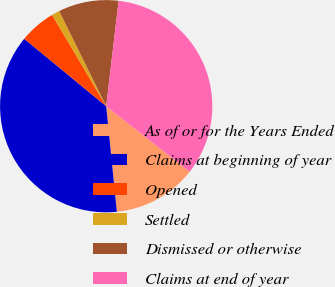Convert chart to OTSL. <chart><loc_0><loc_0><loc_500><loc_500><pie_chart><fcel>As of or for the Years Ended<fcel>Claims at beginning of year<fcel>Opened<fcel>Settled<fcel>Dismissed or otherwise<fcel>Claims at end of year<nl><fcel>12.8%<fcel>37.56%<fcel>5.53%<fcel>1.21%<fcel>9.17%<fcel>33.73%<nl></chart> 